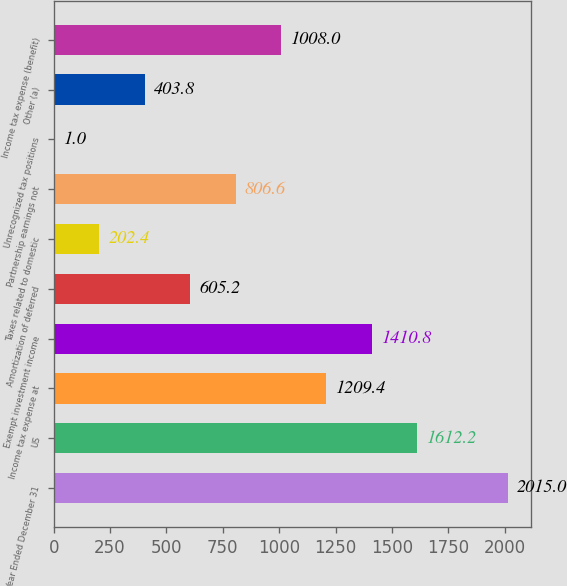Convert chart to OTSL. <chart><loc_0><loc_0><loc_500><loc_500><bar_chart><fcel>Year Ended December 31<fcel>US<fcel>Income tax expense at<fcel>Exempt investment income<fcel>Amortization of deferred<fcel>Taxes related to domestic<fcel>Partnership earnings not<fcel>Unrecognized tax positions<fcel>Other (a)<fcel>Income tax expense (benefit)<nl><fcel>2015<fcel>1612.2<fcel>1209.4<fcel>1410.8<fcel>605.2<fcel>202.4<fcel>806.6<fcel>1<fcel>403.8<fcel>1008<nl></chart> 